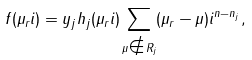Convert formula to latex. <formula><loc_0><loc_0><loc_500><loc_500>f ( \mu _ { r } i ) = y _ { j } h _ { j } ( \mu _ { r } i ) \sum _ { \mu \notin R _ { j } } ( \mu _ { r } - \mu ) i ^ { n - n _ { j } } ,</formula> 